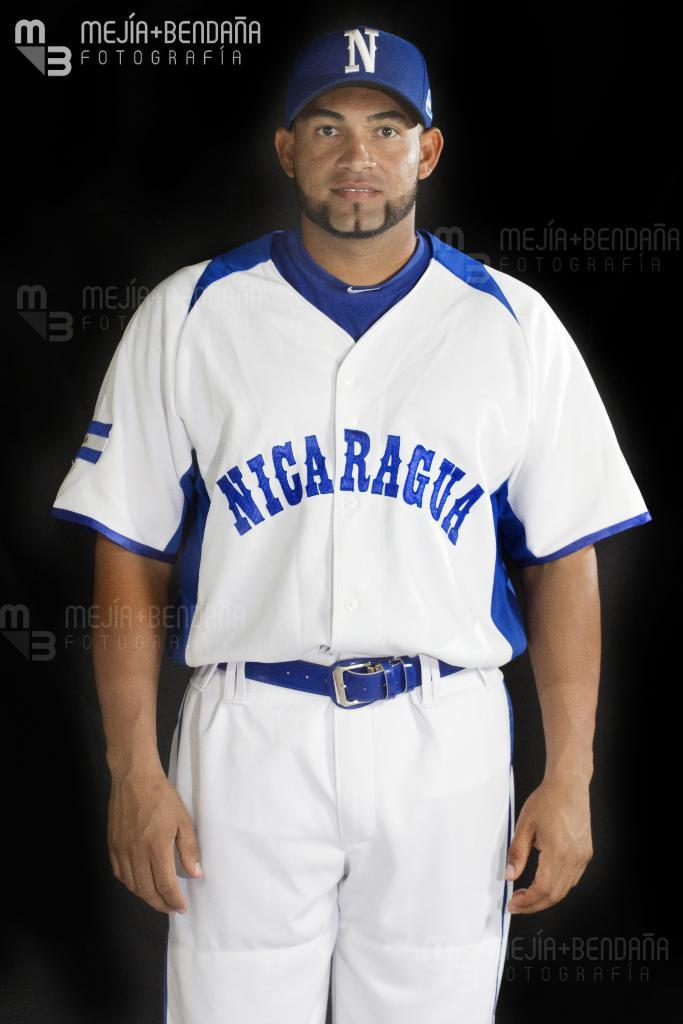<image>
Render a clear and concise summary of the photo. A baseball player for Nicaragua stands posing for a photo. 